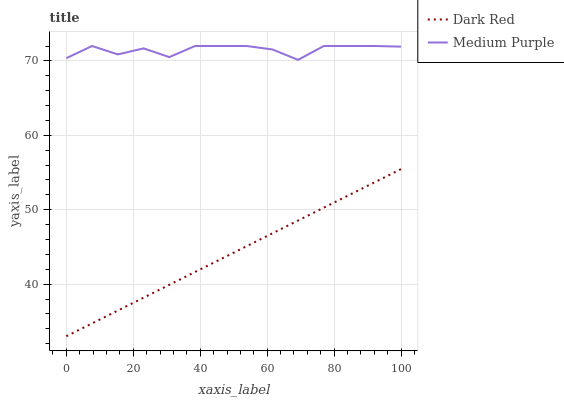Does Dark Red have the minimum area under the curve?
Answer yes or no. Yes. Does Medium Purple have the maximum area under the curve?
Answer yes or no. Yes. Does Dark Red have the maximum area under the curve?
Answer yes or no. No. Is Dark Red the smoothest?
Answer yes or no. Yes. Is Medium Purple the roughest?
Answer yes or no. Yes. Is Dark Red the roughest?
Answer yes or no. No. Does Dark Red have the lowest value?
Answer yes or no. Yes. Does Medium Purple have the highest value?
Answer yes or no. Yes. Does Dark Red have the highest value?
Answer yes or no. No. Is Dark Red less than Medium Purple?
Answer yes or no. Yes. Is Medium Purple greater than Dark Red?
Answer yes or no. Yes. Does Dark Red intersect Medium Purple?
Answer yes or no. No. 